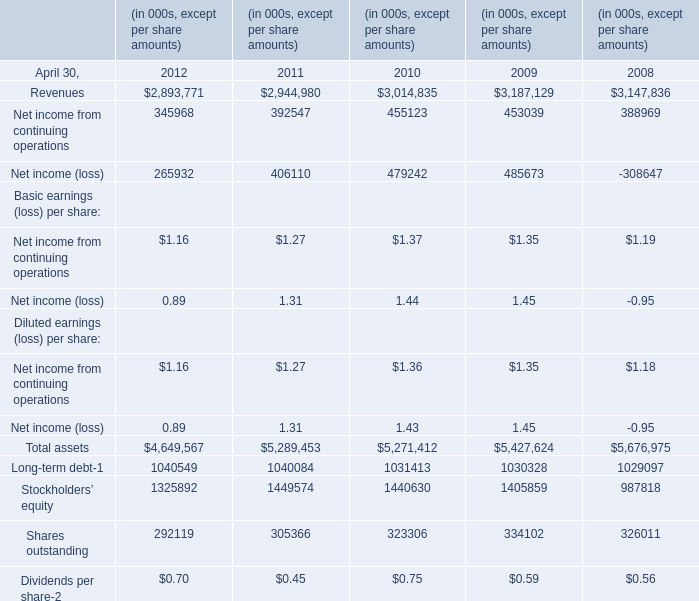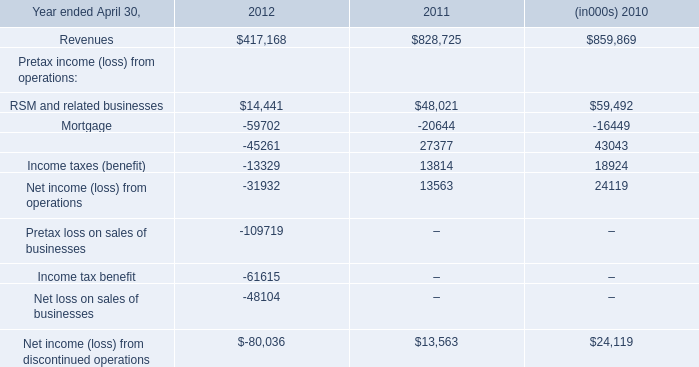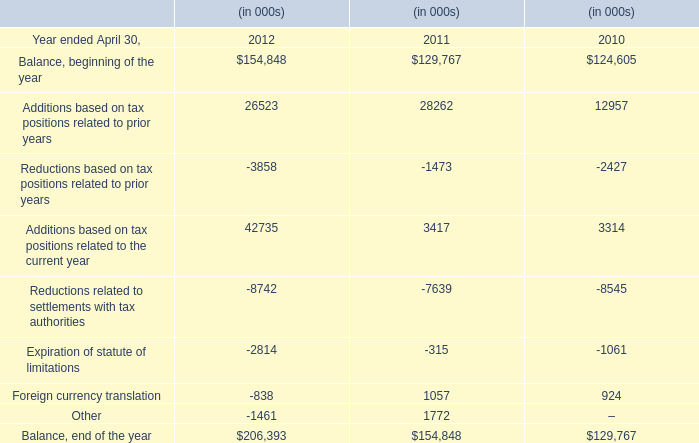If Total assets develops with the same increasing rate at April 30,2011, what will it reach at April 30,2012? (in thousand) 
Computations: (5289453 * (1 + ((5289453 - 5271412) / 5271412)))
Answer: 5307555.74393. 